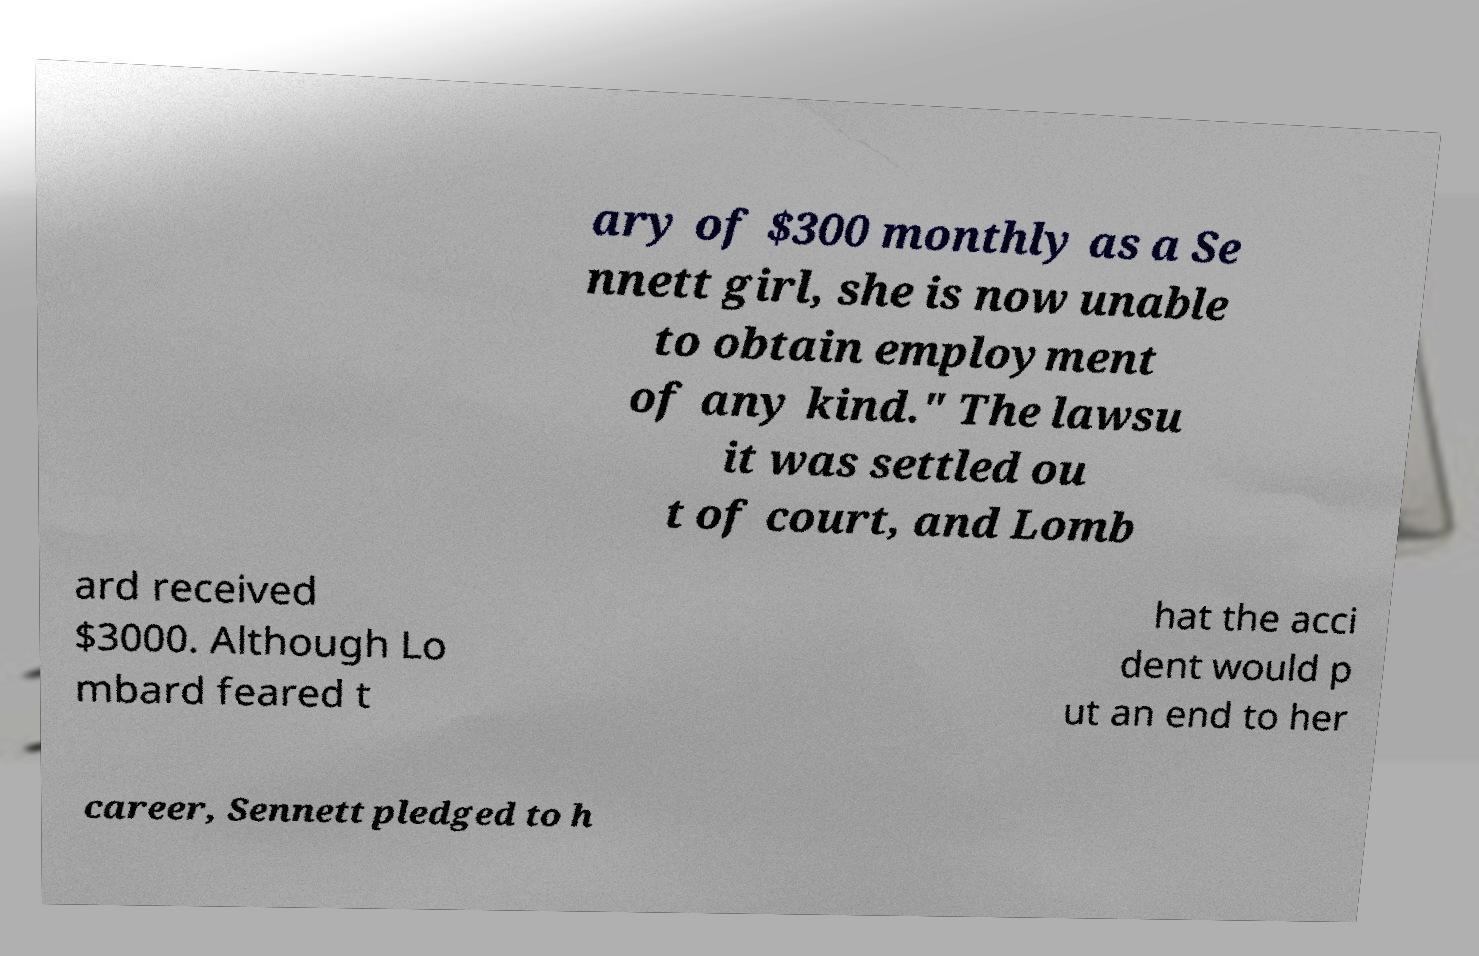There's text embedded in this image that I need extracted. Can you transcribe it verbatim? ary of $300 monthly as a Se nnett girl, she is now unable to obtain employment of any kind." The lawsu it was settled ou t of court, and Lomb ard received $3000. Although Lo mbard feared t hat the acci dent would p ut an end to her career, Sennett pledged to h 